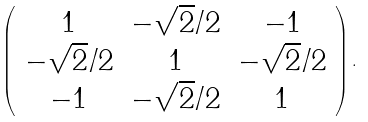<formula> <loc_0><loc_0><loc_500><loc_500>\left ( \begin{array} { c c c } 1 & - \sqrt { 2 } / 2 & - 1 \\ - \sqrt { 2 } / 2 & 1 & - \sqrt { 2 } / 2 \\ - 1 & - \sqrt { 2 } / 2 & 1 \\ \end{array} \right ) .</formula> 